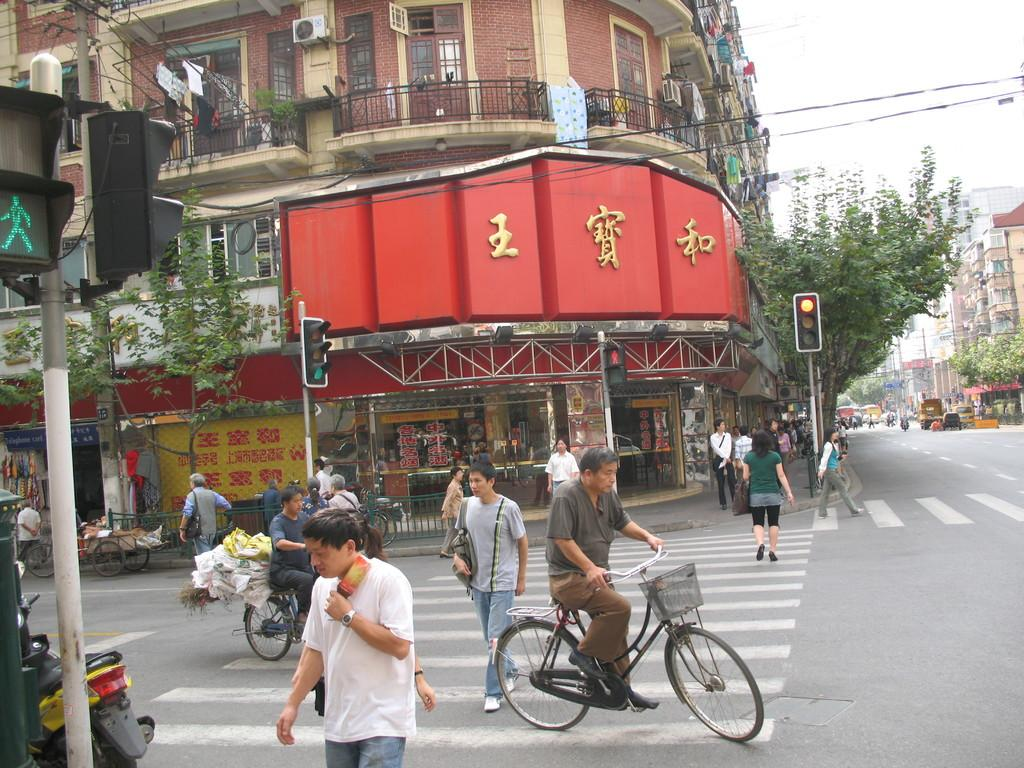What type of structure is present in the image? There is a building in the image. What are the people in the image doing? The people in the image are walking on the road. Can you describe any other forms of transportation in the image? Yes, there is a person riding a bicycle in the image. What can be seen in the background of the image? There are trees visible in the image. Where is the volleyball court located in the image? There is no volleyball court present in the image. 